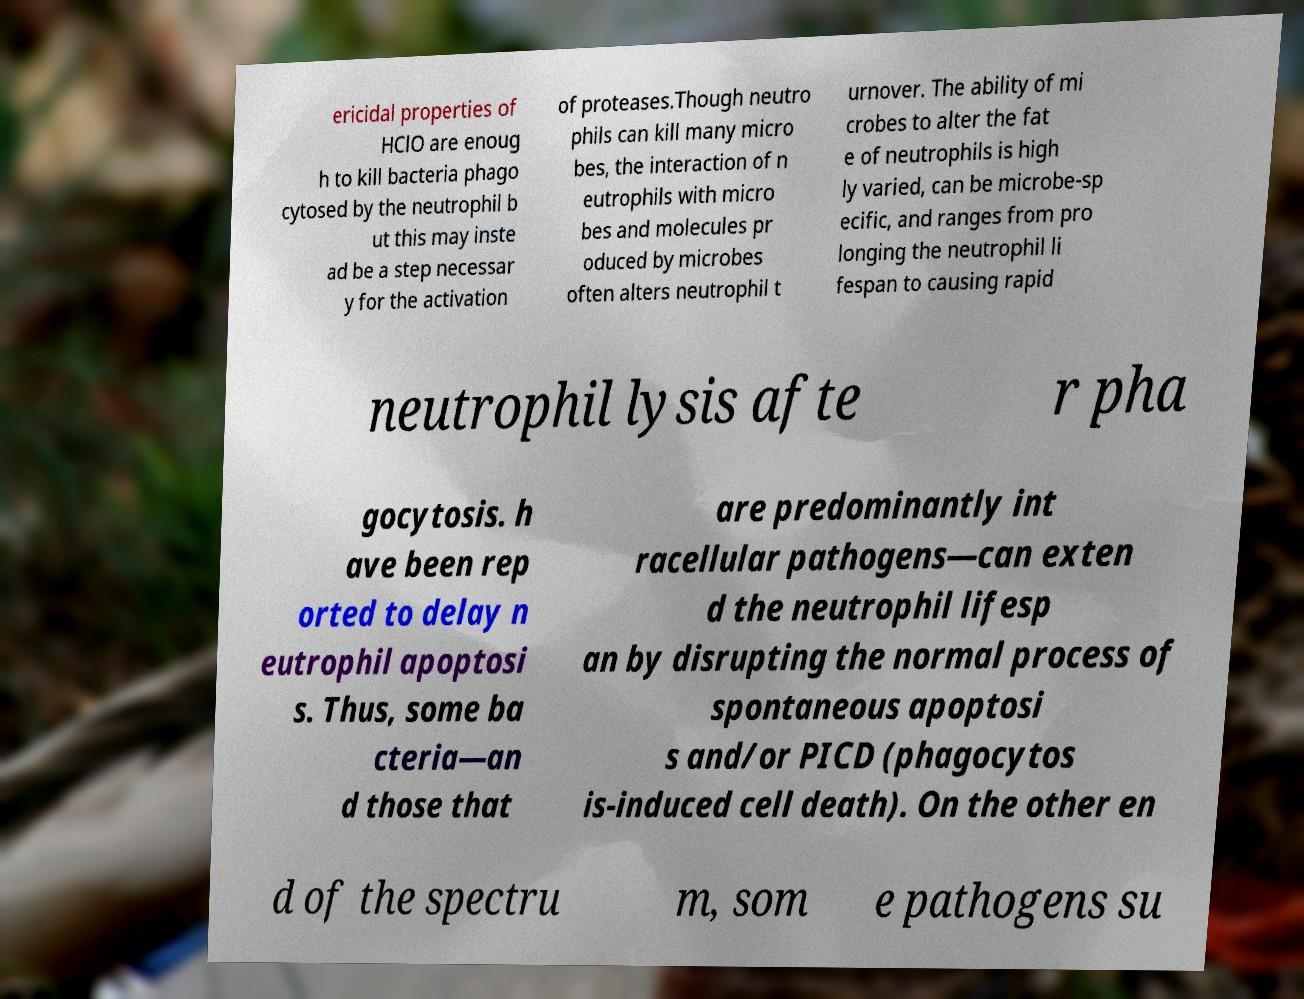Can you accurately transcribe the text from the provided image for me? ericidal properties of HClO are enoug h to kill bacteria phago cytosed by the neutrophil b ut this may inste ad be a step necessar y for the activation of proteases.Though neutro phils can kill many micro bes, the interaction of n eutrophils with micro bes and molecules pr oduced by microbes often alters neutrophil t urnover. The ability of mi crobes to alter the fat e of neutrophils is high ly varied, can be microbe-sp ecific, and ranges from pro longing the neutrophil li fespan to causing rapid neutrophil lysis afte r pha gocytosis. h ave been rep orted to delay n eutrophil apoptosi s. Thus, some ba cteria—an d those that are predominantly int racellular pathogens—can exten d the neutrophil lifesp an by disrupting the normal process of spontaneous apoptosi s and/or PICD (phagocytos is-induced cell death). On the other en d of the spectru m, som e pathogens su 